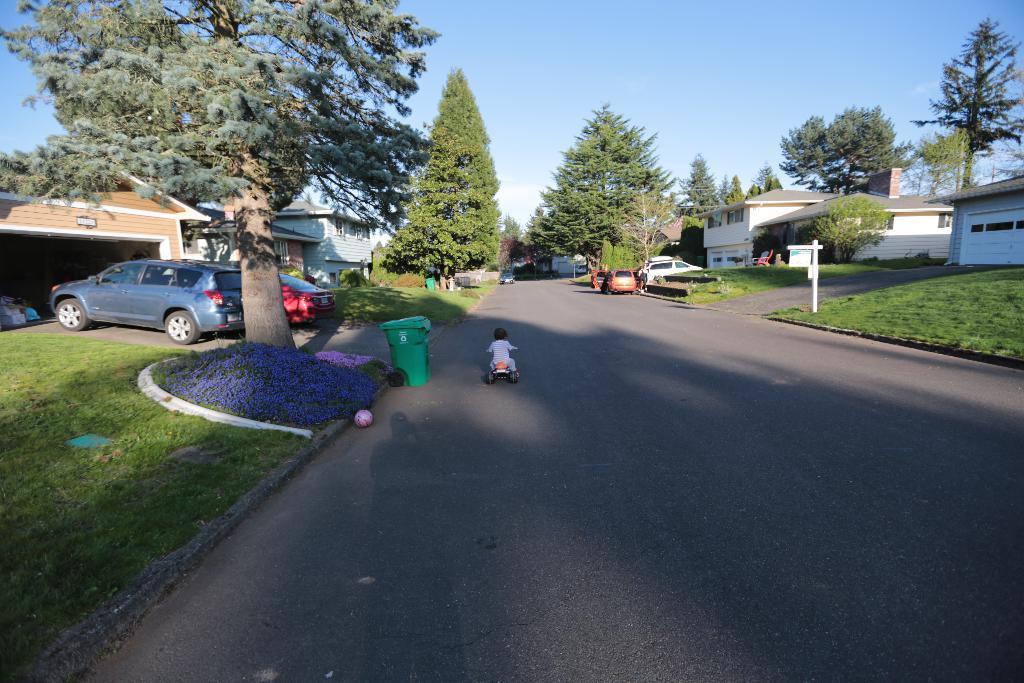Describe this image in one or two sentences. In this image there is a baby with a vehicle on the road. Image also consists of many buildings and also trees. Few cars are parked. Dustbins are also visible in this image. At the top there is sky. 